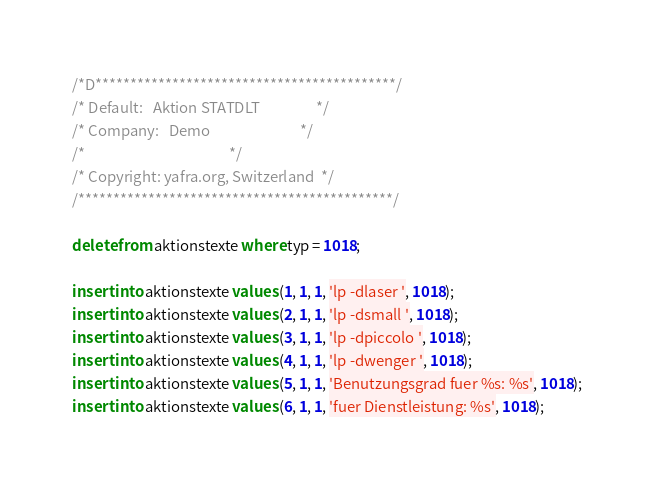Convert code to text. <code><loc_0><loc_0><loc_500><loc_500><_SQL_>/*D*******************************************/
/* Default:   Aktion STATDLT                 */
/* Company:   Demo                           */
/*                                           */
/* Copyright: yafra.org, Switzerland  */  
/*********************************************/

delete from aktionstexte where typ = 1018;

insert into aktionstexte values (1, 1, 1, 'lp -dlaser ', 1018); 
insert into aktionstexte values (2, 1, 1, 'lp -dsmall ', 1018); 
insert into aktionstexte values (3, 1, 1, 'lp -dpiccolo ', 1018); 
insert into aktionstexte values (4, 1, 1, 'lp -dwenger ', 1018); 
insert into aktionstexte values (5, 1, 1, 'Benutzungsgrad fuer %s: %s', 1018);
insert into aktionstexte values (6, 1, 1, 'fuer Dienstleistung: %s', 1018);</code> 